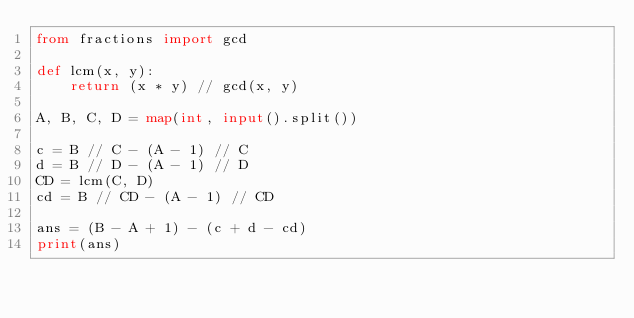<code> <loc_0><loc_0><loc_500><loc_500><_Python_>from fractions import gcd

def lcm(x, y):
    return (x * y) // gcd(x, y)

A, B, C, D = map(int, input().split())

c = B // C - (A - 1) // C
d = B // D - (A - 1) // D
CD = lcm(C, D)
cd = B // CD - (A - 1) // CD

ans = (B - A + 1) - (c + d - cd)
print(ans)</code> 